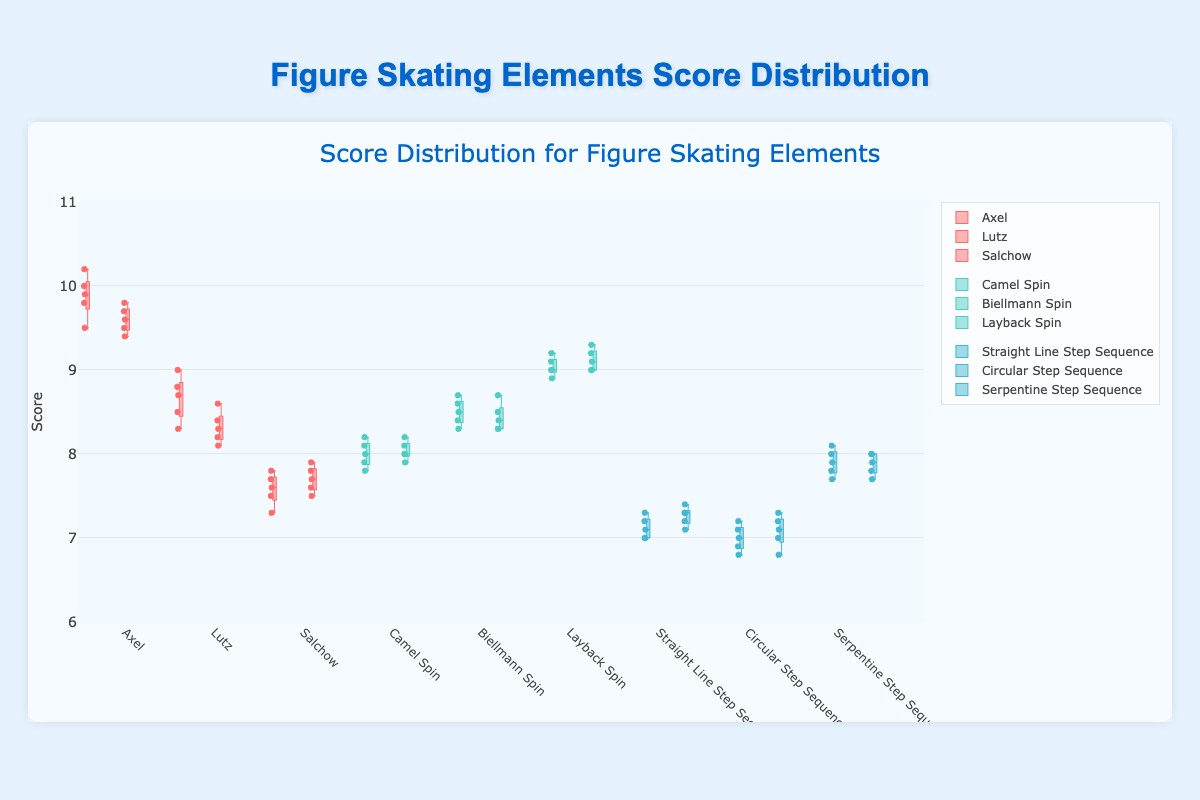What's the title of the chart? The title is displayed at the top of the chart. It reads: "Score Distribution for Figure Skating Elements".
Answer: Score Distribution for Figure Skating Elements What is the range of the y-axis? The range of the y-axis can be seen on the left side of the chart. It goes from 6 to 11.
Answer: 6 to 11 Which element has the highest median score in the Grand Prix of Figure Skating Final for 2021? For the Grand Prix competition, compare the median lines (usually the line inside the box) for all elements. Layback Spin has the highest median score.
Answer: Layback Spin What is the interquartile range (IQR) for the Camel Spin scores in the World Figure Skating Championships 2022? The IQR is the difference between the third quartile (Q3) and the first quartile (Q1). For Camel Spin, identify Q3 and Q1 on the box plot and calculate the difference.
Answer: approximately 0.4 (8.2 - 7.8) Which spin element shows the least variation in scores in the World Figure Skating Championships 2022? Variation can be observed by the spread of the scores. The Camel Spin has the narrowest box, indicating the least variation.
Answer: Camel Spin Which competition had higher variability in Axel jumps' scores? Compare the spread of the 'Axel' box plot between the two competitions. The World Figure Skating Championships 2022 has a wider box and whiskers, indicating higher variability.
Answer: World Figure Skating Championships What is the median score for the Biellmann Spin in the World Figure Skating Championships 2022? Find the middle line of the box representing the Biellmann Spin in this competition. The median score is where this line is located.
Answer: 8.5 How do the Salchow scores compare between the two competitions? Compare the median lines, box heights, and whisker lengths of the Salchow elements from both competitions. The median scores are similar, but the World Figure Skating Championships 2022 has slightly less variability.
Answer: Similar median, less variability in World Championships 